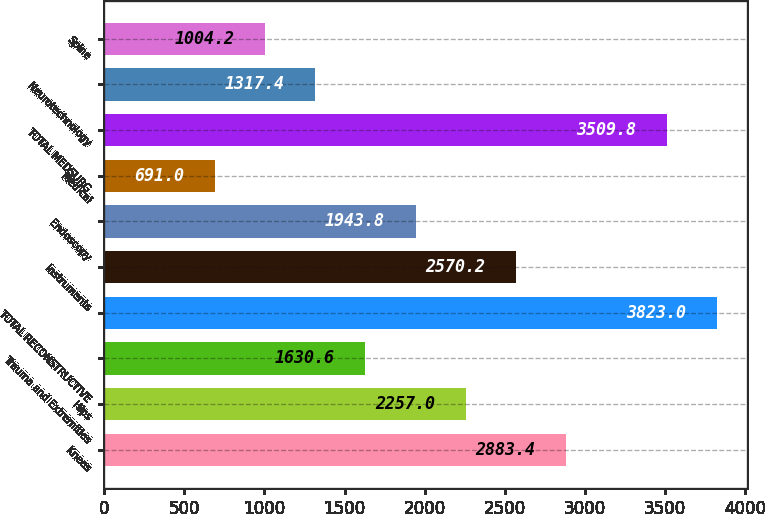Convert chart. <chart><loc_0><loc_0><loc_500><loc_500><bar_chart><fcel>Knees<fcel>Hips<fcel>Trauma and Extremities<fcel>TOTAL RECONSTRUCTIVE<fcel>Instruments<fcel>Endoscopy<fcel>Medical<fcel>TOTAL MEDSURG<fcel>Neurotechnology<fcel>Spine<nl><fcel>2883.4<fcel>2257<fcel>1630.6<fcel>3823<fcel>2570.2<fcel>1943.8<fcel>691<fcel>3509.8<fcel>1317.4<fcel>1004.2<nl></chart> 